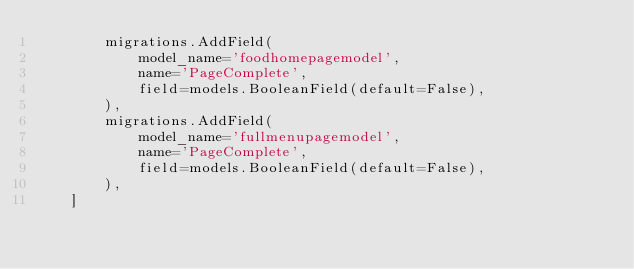Convert code to text. <code><loc_0><loc_0><loc_500><loc_500><_Python_>        migrations.AddField(
            model_name='foodhomepagemodel',
            name='PageComplete',
            field=models.BooleanField(default=False),
        ),
        migrations.AddField(
            model_name='fullmenupagemodel',
            name='PageComplete',
            field=models.BooleanField(default=False),
        ),
    ]
</code> 